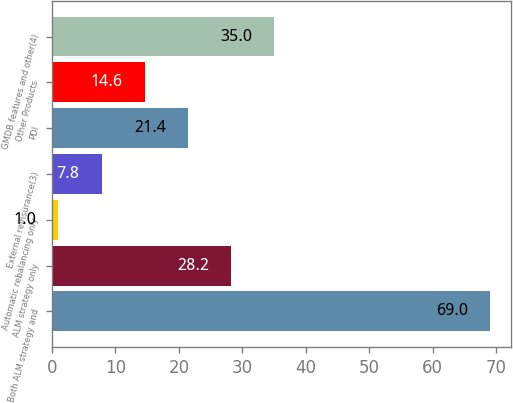Convert chart to OTSL. <chart><loc_0><loc_0><loc_500><loc_500><bar_chart><fcel>Both ALM strategy and<fcel>ALM strategy only<fcel>Automatic rebalancing only<fcel>External reinsurance(3)<fcel>PDI<fcel>Other Products<fcel>GMDB features and other(4)<nl><fcel>69<fcel>28.2<fcel>1<fcel>7.8<fcel>21.4<fcel>14.6<fcel>35<nl></chart> 